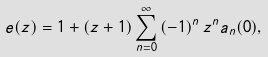Convert formula to latex. <formula><loc_0><loc_0><loc_500><loc_500>e ( z ) = 1 + \left ( z + 1 \right ) \sum _ { n = 0 } ^ { \infty } \left ( - 1 \right ) ^ { n } z ^ { n } a _ { n } ( 0 ) ,</formula> 